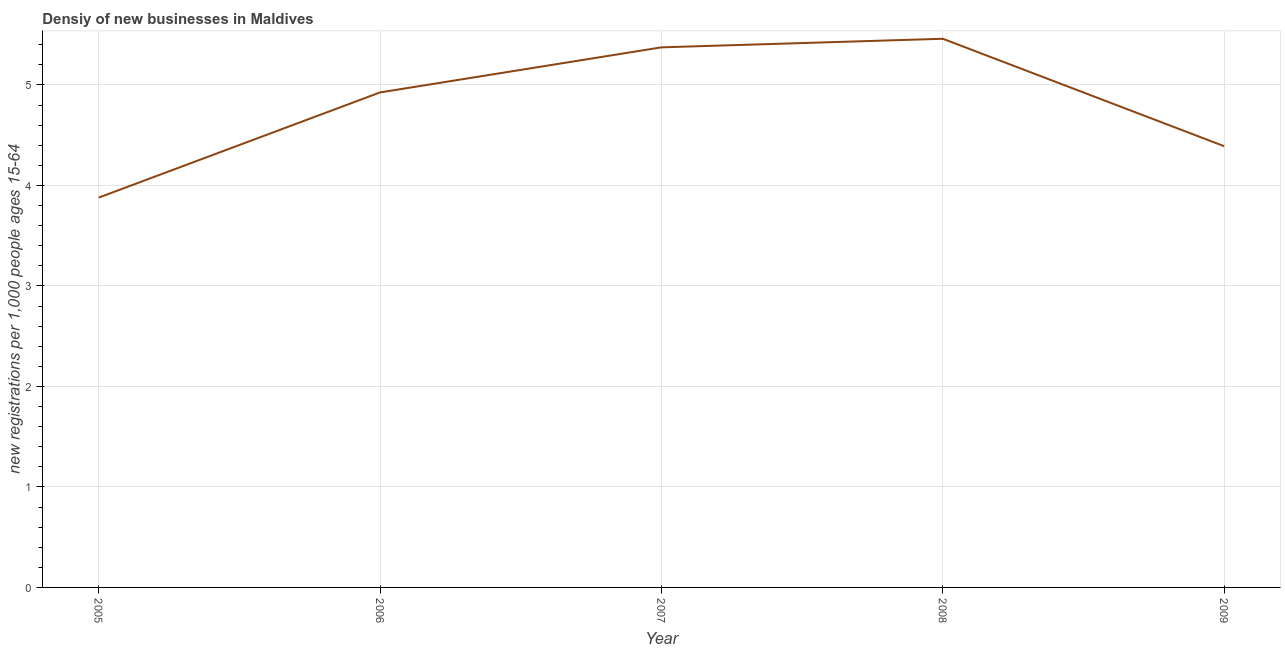What is the density of new business in 2006?
Provide a succinct answer. 4.93. Across all years, what is the maximum density of new business?
Your response must be concise. 5.46. Across all years, what is the minimum density of new business?
Offer a very short reply. 3.88. In which year was the density of new business minimum?
Make the answer very short. 2005. What is the sum of the density of new business?
Provide a succinct answer. 24.03. What is the difference between the density of new business in 2007 and 2009?
Give a very brief answer. 0.98. What is the average density of new business per year?
Give a very brief answer. 4.81. What is the median density of new business?
Make the answer very short. 4.93. In how many years, is the density of new business greater than 2.4 ?
Make the answer very short. 5. What is the ratio of the density of new business in 2005 to that in 2009?
Your answer should be very brief. 0.88. Is the density of new business in 2006 less than that in 2007?
Ensure brevity in your answer.  Yes. What is the difference between the highest and the second highest density of new business?
Give a very brief answer. 0.09. Is the sum of the density of new business in 2005 and 2007 greater than the maximum density of new business across all years?
Offer a terse response. Yes. What is the difference between the highest and the lowest density of new business?
Make the answer very short. 1.58. Does the density of new business monotonically increase over the years?
Ensure brevity in your answer.  No. What is the difference between two consecutive major ticks on the Y-axis?
Your answer should be compact. 1. Does the graph contain grids?
Provide a short and direct response. Yes. What is the title of the graph?
Offer a terse response. Densiy of new businesses in Maldives. What is the label or title of the Y-axis?
Keep it short and to the point. New registrations per 1,0 people ages 15-64. What is the new registrations per 1,000 people ages 15-64 in 2005?
Offer a terse response. 3.88. What is the new registrations per 1,000 people ages 15-64 of 2006?
Keep it short and to the point. 4.93. What is the new registrations per 1,000 people ages 15-64 of 2007?
Make the answer very short. 5.37. What is the new registrations per 1,000 people ages 15-64 of 2008?
Make the answer very short. 5.46. What is the new registrations per 1,000 people ages 15-64 of 2009?
Ensure brevity in your answer.  4.39. What is the difference between the new registrations per 1,000 people ages 15-64 in 2005 and 2006?
Give a very brief answer. -1.05. What is the difference between the new registrations per 1,000 people ages 15-64 in 2005 and 2007?
Make the answer very short. -1.5. What is the difference between the new registrations per 1,000 people ages 15-64 in 2005 and 2008?
Ensure brevity in your answer.  -1.58. What is the difference between the new registrations per 1,000 people ages 15-64 in 2005 and 2009?
Your response must be concise. -0.51. What is the difference between the new registrations per 1,000 people ages 15-64 in 2006 and 2007?
Ensure brevity in your answer.  -0.45. What is the difference between the new registrations per 1,000 people ages 15-64 in 2006 and 2008?
Your response must be concise. -0.53. What is the difference between the new registrations per 1,000 people ages 15-64 in 2006 and 2009?
Offer a very short reply. 0.54. What is the difference between the new registrations per 1,000 people ages 15-64 in 2007 and 2008?
Offer a very short reply. -0.09. What is the difference between the new registrations per 1,000 people ages 15-64 in 2007 and 2009?
Provide a succinct answer. 0.98. What is the difference between the new registrations per 1,000 people ages 15-64 in 2008 and 2009?
Give a very brief answer. 1.07. What is the ratio of the new registrations per 1,000 people ages 15-64 in 2005 to that in 2006?
Offer a terse response. 0.79. What is the ratio of the new registrations per 1,000 people ages 15-64 in 2005 to that in 2007?
Provide a succinct answer. 0.72. What is the ratio of the new registrations per 1,000 people ages 15-64 in 2005 to that in 2008?
Offer a very short reply. 0.71. What is the ratio of the new registrations per 1,000 people ages 15-64 in 2005 to that in 2009?
Make the answer very short. 0.88. What is the ratio of the new registrations per 1,000 people ages 15-64 in 2006 to that in 2007?
Your answer should be compact. 0.92. What is the ratio of the new registrations per 1,000 people ages 15-64 in 2006 to that in 2008?
Give a very brief answer. 0.9. What is the ratio of the new registrations per 1,000 people ages 15-64 in 2006 to that in 2009?
Your answer should be compact. 1.12. What is the ratio of the new registrations per 1,000 people ages 15-64 in 2007 to that in 2009?
Keep it short and to the point. 1.22. What is the ratio of the new registrations per 1,000 people ages 15-64 in 2008 to that in 2009?
Ensure brevity in your answer.  1.24. 